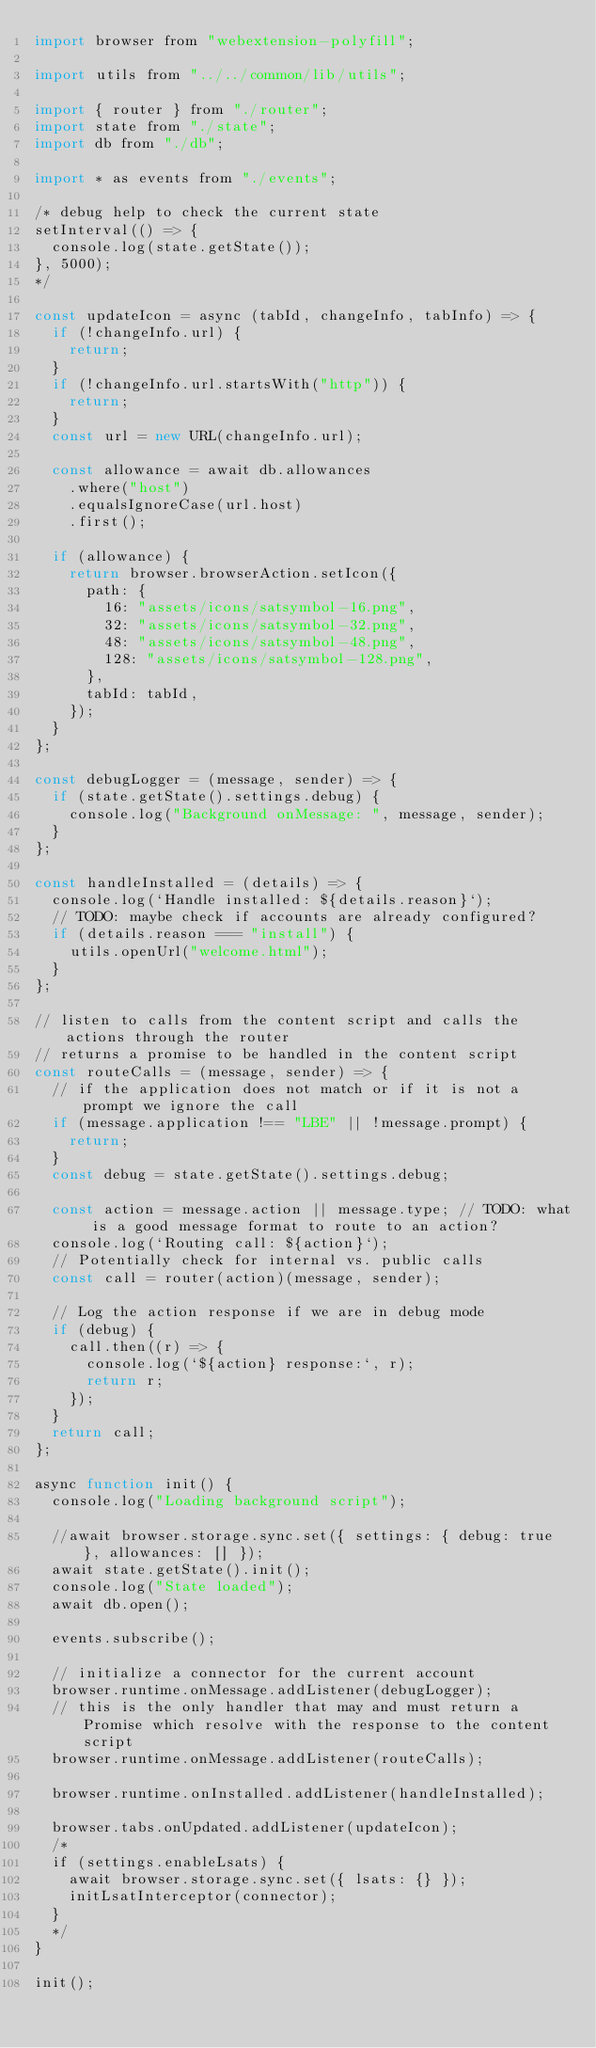Convert code to text. <code><loc_0><loc_0><loc_500><loc_500><_JavaScript_>import browser from "webextension-polyfill";

import utils from "../../common/lib/utils";

import { router } from "./router";
import state from "./state";
import db from "./db";

import * as events from "./events";

/* debug help to check the current state
setInterval(() => {
  console.log(state.getState());
}, 5000);
*/

const updateIcon = async (tabId, changeInfo, tabInfo) => {
  if (!changeInfo.url) {
    return;
  }
  if (!changeInfo.url.startsWith("http")) {
    return;
  }
  const url = new URL(changeInfo.url);

  const allowance = await db.allowances
    .where("host")
    .equalsIgnoreCase(url.host)
    .first();

  if (allowance) {
    return browser.browserAction.setIcon({
      path: {
        16: "assets/icons/satsymbol-16.png",
        32: "assets/icons/satsymbol-32.png",
        48: "assets/icons/satsymbol-48.png",
        128: "assets/icons/satsymbol-128.png",
      },
      tabId: tabId,
    });
  }
};

const debugLogger = (message, sender) => {
  if (state.getState().settings.debug) {
    console.log("Background onMessage: ", message, sender);
  }
};

const handleInstalled = (details) => {
  console.log(`Handle installed: ${details.reason}`);
  // TODO: maybe check if accounts are already configured?
  if (details.reason === "install") {
    utils.openUrl("welcome.html");
  }
};

// listen to calls from the content script and calls the actions through the router
// returns a promise to be handled in the content script
const routeCalls = (message, sender) => {
  // if the application does not match or if it is not a prompt we ignore the call
  if (message.application !== "LBE" || !message.prompt) {
    return;
  }
  const debug = state.getState().settings.debug;

  const action = message.action || message.type; // TODO: what is a good message format to route to an action?
  console.log(`Routing call: ${action}`);
  // Potentially check for internal vs. public calls
  const call = router(action)(message, sender);

  // Log the action response if we are in debug mode
  if (debug) {
    call.then((r) => {
      console.log(`${action} response:`, r);
      return r;
    });
  }
  return call;
};

async function init() {
  console.log("Loading background script");

  //await browser.storage.sync.set({ settings: { debug: true }, allowances: [] });
  await state.getState().init();
  console.log("State loaded");
  await db.open();

  events.subscribe();

  // initialize a connector for the current account
  browser.runtime.onMessage.addListener(debugLogger);
  // this is the only handler that may and must return a Promise which resolve with the response to the content script
  browser.runtime.onMessage.addListener(routeCalls);

  browser.runtime.onInstalled.addListener(handleInstalled);

  browser.tabs.onUpdated.addListener(updateIcon);
  /*
  if (settings.enableLsats) {
    await browser.storage.sync.set({ lsats: {} });
    initLsatInterceptor(connector);
  }
  */
}

init();
</code> 